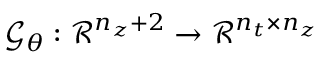Convert formula to latex. <formula><loc_0><loc_0><loc_500><loc_500>\mathcal { G } _ { \boldsymbol \theta } \colon \mathcal { R } ^ { n _ { z } + 2 } \rightarrow \mathcal { R } ^ { n _ { t } \times n _ { z } }</formula> 